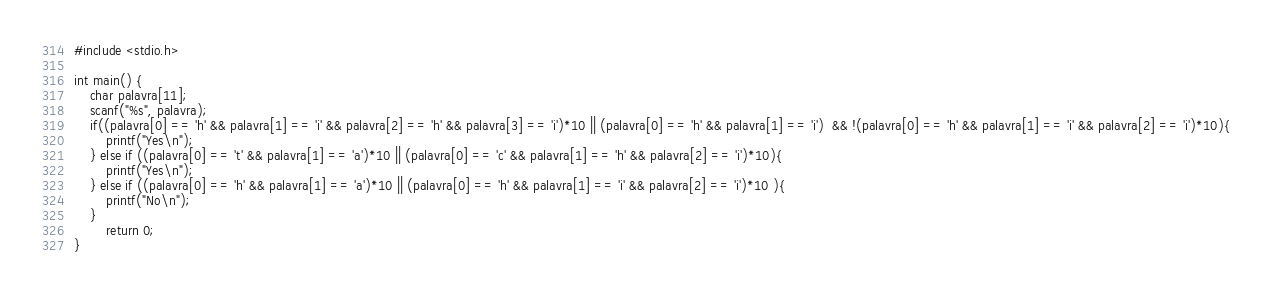<code> <loc_0><loc_0><loc_500><loc_500><_C_>#include <stdio.h>
         
int main() {
    char palavra[11];
    scanf("%s", palavra);
    if((palavra[0] == 'h' && palavra[1] == 'i' && palavra[2] == 'h' && palavra[3] == 'i')*10 || (palavra[0] == 'h' && palavra[1] == 'i')  && !(palavra[0] == 'h' && palavra[1] == 'i' && palavra[2] == 'i')*10){
        printf("Yes\n");
    } else if ((palavra[0] == 't' && palavra[1] == 'a')*10 || (palavra[0] == 'c' && palavra[1] == 'h' && palavra[2] == 'i')*10){
        printf("Yes\n");   
    } else if ((palavra[0] == 'h' && palavra[1] == 'a')*10 || (palavra[0] == 'h' && palavra[1] == 'i' && palavra[2] == 'i')*10 ){
        printf("No\n");
    }
        return 0;
}</code> 